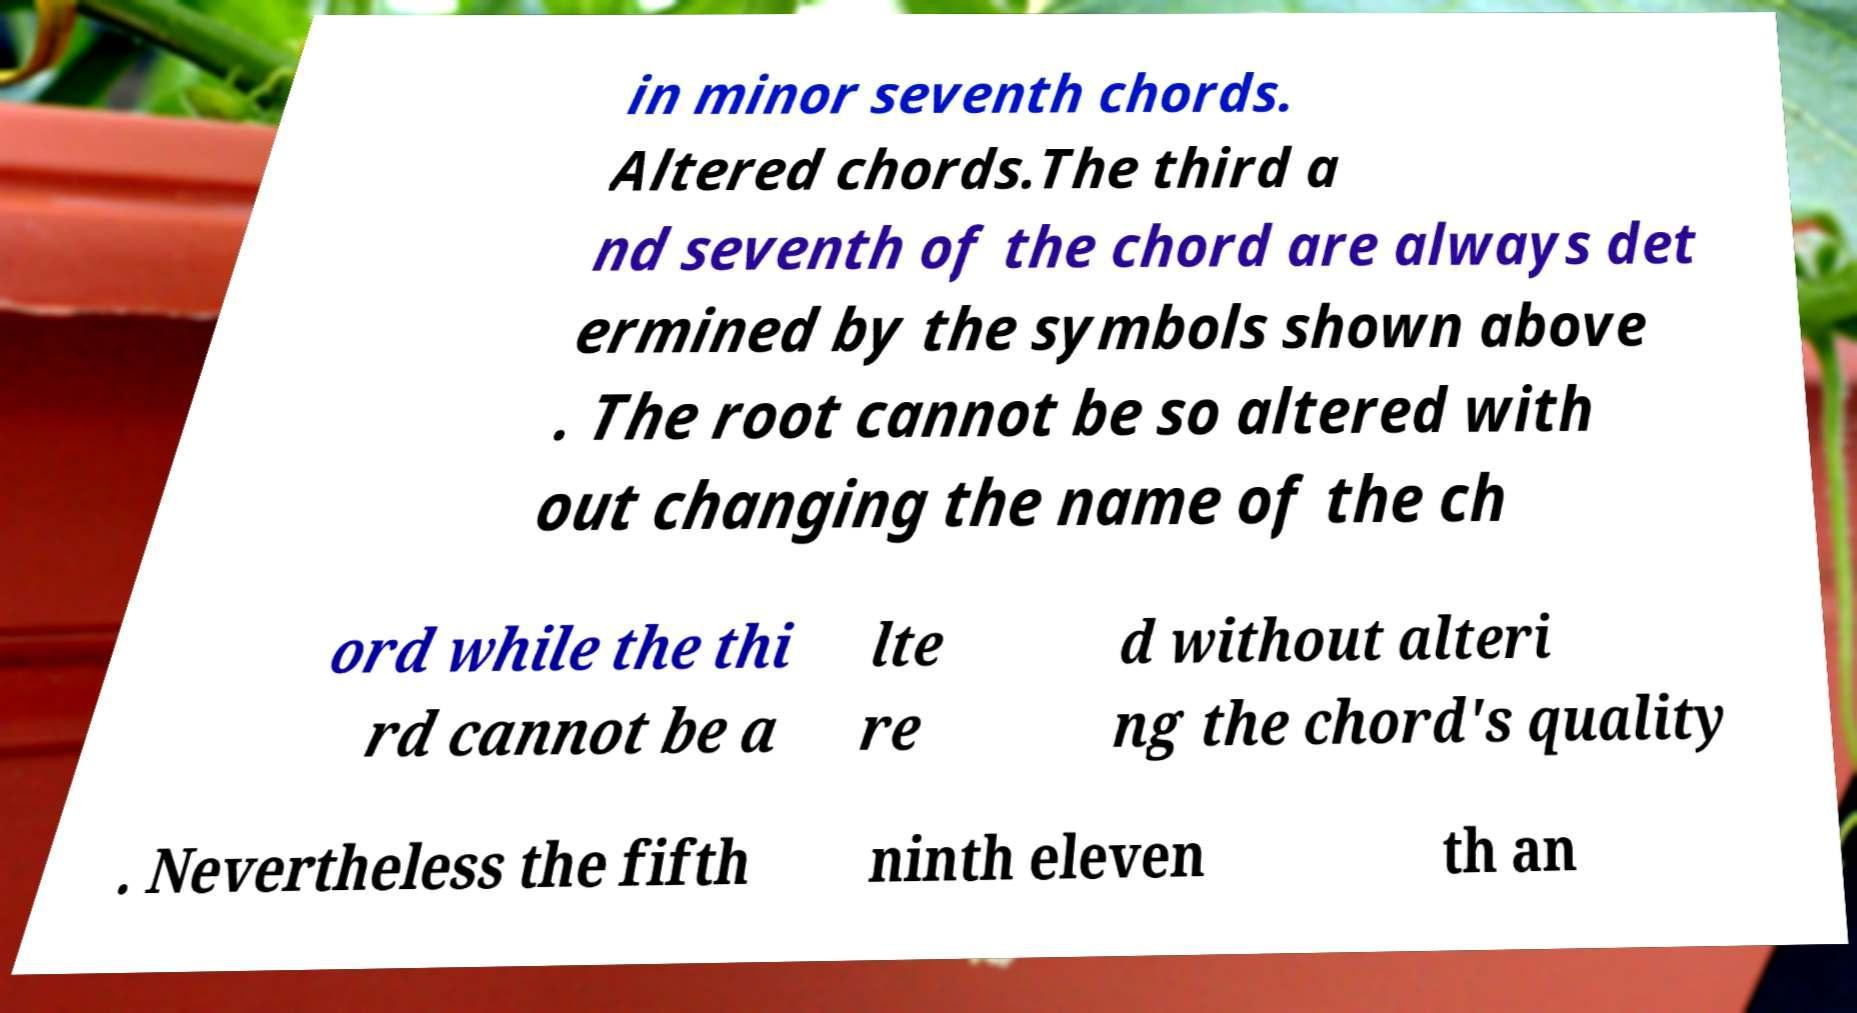For documentation purposes, I need the text within this image transcribed. Could you provide that? in minor seventh chords. Altered chords.The third a nd seventh of the chord are always det ermined by the symbols shown above . The root cannot be so altered with out changing the name of the ch ord while the thi rd cannot be a lte re d without alteri ng the chord's quality . Nevertheless the fifth ninth eleven th an 